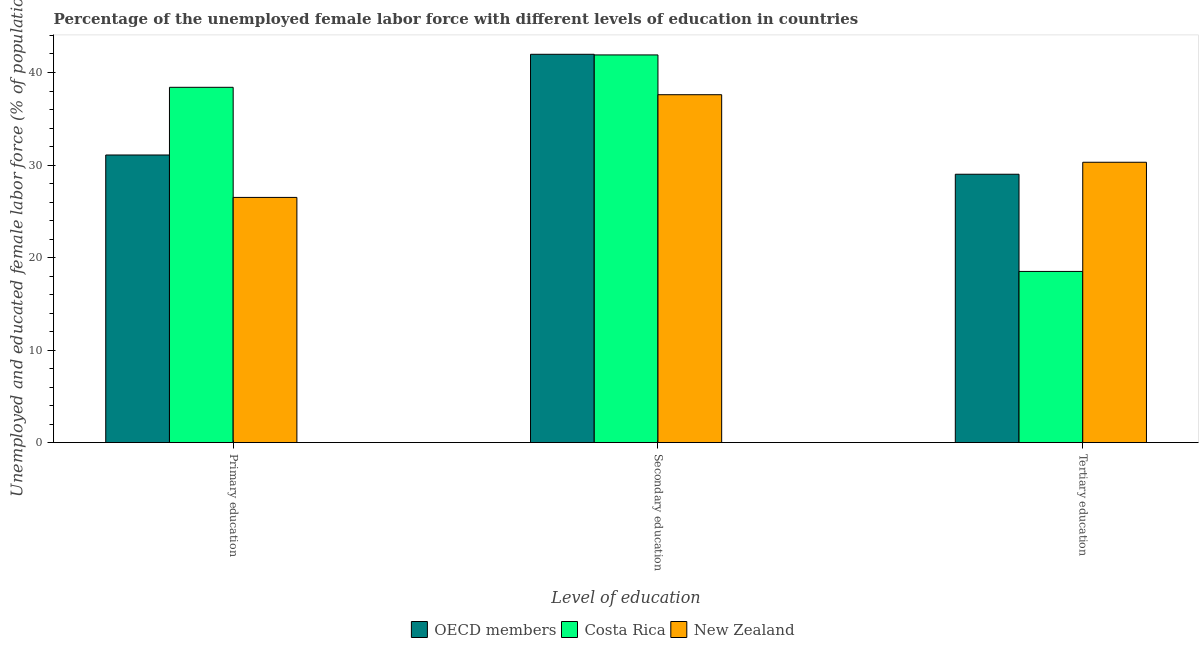How many groups of bars are there?
Offer a terse response. 3. Are the number of bars per tick equal to the number of legend labels?
Your answer should be compact. Yes. Are the number of bars on each tick of the X-axis equal?
Provide a succinct answer. Yes. How many bars are there on the 3rd tick from the left?
Your response must be concise. 3. How many bars are there on the 2nd tick from the right?
Your answer should be compact. 3. What is the label of the 2nd group of bars from the left?
Give a very brief answer. Secondary education. What is the percentage of female labor force who received primary education in OECD members?
Make the answer very short. 31.08. Across all countries, what is the maximum percentage of female labor force who received secondary education?
Offer a terse response. 41.97. In which country was the percentage of female labor force who received secondary education maximum?
Give a very brief answer. OECD members. In which country was the percentage of female labor force who received primary education minimum?
Provide a succinct answer. New Zealand. What is the total percentage of female labor force who received tertiary education in the graph?
Ensure brevity in your answer.  77.81. What is the difference between the percentage of female labor force who received primary education in Costa Rica and that in OECD members?
Your response must be concise. 7.32. What is the difference between the percentage of female labor force who received primary education in New Zealand and the percentage of female labor force who received secondary education in Costa Rica?
Offer a terse response. -15.4. What is the average percentage of female labor force who received secondary education per country?
Your response must be concise. 40.49. What is the difference between the percentage of female labor force who received tertiary education and percentage of female labor force who received secondary education in New Zealand?
Offer a very short reply. -7.3. What is the ratio of the percentage of female labor force who received tertiary education in New Zealand to that in Costa Rica?
Keep it short and to the point. 1.64. What is the difference between the highest and the second highest percentage of female labor force who received primary education?
Make the answer very short. 7.32. What is the difference between the highest and the lowest percentage of female labor force who received primary education?
Provide a short and direct response. 11.9. In how many countries, is the percentage of female labor force who received tertiary education greater than the average percentage of female labor force who received tertiary education taken over all countries?
Provide a short and direct response. 2. Is the sum of the percentage of female labor force who received tertiary education in Costa Rica and New Zealand greater than the maximum percentage of female labor force who received primary education across all countries?
Offer a very short reply. Yes. What does the 1st bar from the right in Secondary education represents?
Keep it short and to the point. New Zealand. Is it the case that in every country, the sum of the percentage of female labor force who received primary education and percentage of female labor force who received secondary education is greater than the percentage of female labor force who received tertiary education?
Ensure brevity in your answer.  Yes. How many bars are there?
Your answer should be compact. 9. Are all the bars in the graph horizontal?
Offer a terse response. No. Does the graph contain any zero values?
Offer a very short reply. No. Does the graph contain grids?
Your answer should be compact. No. How are the legend labels stacked?
Your answer should be very brief. Horizontal. What is the title of the graph?
Keep it short and to the point. Percentage of the unemployed female labor force with different levels of education in countries. What is the label or title of the X-axis?
Make the answer very short. Level of education. What is the label or title of the Y-axis?
Give a very brief answer. Unemployed and educated female labor force (% of population). What is the Unemployed and educated female labor force (% of population) in OECD members in Primary education?
Your answer should be very brief. 31.08. What is the Unemployed and educated female labor force (% of population) of Costa Rica in Primary education?
Provide a succinct answer. 38.4. What is the Unemployed and educated female labor force (% of population) in New Zealand in Primary education?
Your answer should be compact. 26.5. What is the Unemployed and educated female labor force (% of population) in OECD members in Secondary education?
Offer a very short reply. 41.97. What is the Unemployed and educated female labor force (% of population) of Costa Rica in Secondary education?
Your answer should be very brief. 41.9. What is the Unemployed and educated female labor force (% of population) in New Zealand in Secondary education?
Offer a terse response. 37.6. What is the Unemployed and educated female labor force (% of population) of OECD members in Tertiary education?
Your answer should be very brief. 29.01. What is the Unemployed and educated female labor force (% of population) in New Zealand in Tertiary education?
Your answer should be compact. 30.3. Across all Level of education, what is the maximum Unemployed and educated female labor force (% of population) in OECD members?
Make the answer very short. 41.97. Across all Level of education, what is the maximum Unemployed and educated female labor force (% of population) of Costa Rica?
Give a very brief answer. 41.9. Across all Level of education, what is the maximum Unemployed and educated female labor force (% of population) in New Zealand?
Offer a very short reply. 37.6. Across all Level of education, what is the minimum Unemployed and educated female labor force (% of population) of OECD members?
Ensure brevity in your answer.  29.01. Across all Level of education, what is the minimum Unemployed and educated female labor force (% of population) of New Zealand?
Offer a very short reply. 26.5. What is the total Unemployed and educated female labor force (% of population) of OECD members in the graph?
Your response must be concise. 102.06. What is the total Unemployed and educated female labor force (% of population) in Costa Rica in the graph?
Your answer should be compact. 98.8. What is the total Unemployed and educated female labor force (% of population) in New Zealand in the graph?
Your answer should be compact. 94.4. What is the difference between the Unemployed and educated female labor force (% of population) in OECD members in Primary education and that in Secondary education?
Make the answer very short. -10.88. What is the difference between the Unemployed and educated female labor force (% of population) of New Zealand in Primary education and that in Secondary education?
Make the answer very short. -11.1. What is the difference between the Unemployed and educated female labor force (% of population) in OECD members in Primary education and that in Tertiary education?
Keep it short and to the point. 2.08. What is the difference between the Unemployed and educated female labor force (% of population) of OECD members in Secondary education and that in Tertiary education?
Provide a short and direct response. 12.96. What is the difference between the Unemployed and educated female labor force (% of population) in Costa Rica in Secondary education and that in Tertiary education?
Provide a succinct answer. 23.4. What is the difference between the Unemployed and educated female labor force (% of population) of New Zealand in Secondary education and that in Tertiary education?
Your answer should be very brief. 7.3. What is the difference between the Unemployed and educated female labor force (% of population) of OECD members in Primary education and the Unemployed and educated female labor force (% of population) of Costa Rica in Secondary education?
Make the answer very short. -10.82. What is the difference between the Unemployed and educated female labor force (% of population) of OECD members in Primary education and the Unemployed and educated female labor force (% of population) of New Zealand in Secondary education?
Offer a terse response. -6.52. What is the difference between the Unemployed and educated female labor force (% of population) of OECD members in Primary education and the Unemployed and educated female labor force (% of population) of Costa Rica in Tertiary education?
Offer a terse response. 12.58. What is the difference between the Unemployed and educated female labor force (% of population) in OECD members in Primary education and the Unemployed and educated female labor force (% of population) in New Zealand in Tertiary education?
Make the answer very short. 0.78. What is the difference between the Unemployed and educated female labor force (% of population) in Costa Rica in Primary education and the Unemployed and educated female labor force (% of population) in New Zealand in Tertiary education?
Make the answer very short. 8.1. What is the difference between the Unemployed and educated female labor force (% of population) in OECD members in Secondary education and the Unemployed and educated female labor force (% of population) in Costa Rica in Tertiary education?
Make the answer very short. 23.47. What is the difference between the Unemployed and educated female labor force (% of population) of OECD members in Secondary education and the Unemployed and educated female labor force (% of population) of New Zealand in Tertiary education?
Offer a very short reply. 11.67. What is the difference between the Unemployed and educated female labor force (% of population) of Costa Rica in Secondary education and the Unemployed and educated female labor force (% of population) of New Zealand in Tertiary education?
Provide a short and direct response. 11.6. What is the average Unemployed and educated female labor force (% of population) of OECD members per Level of education?
Your response must be concise. 34.02. What is the average Unemployed and educated female labor force (% of population) of Costa Rica per Level of education?
Your answer should be compact. 32.93. What is the average Unemployed and educated female labor force (% of population) of New Zealand per Level of education?
Provide a succinct answer. 31.47. What is the difference between the Unemployed and educated female labor force (% of population) in OECD members and Unemployed and educated female labor force (% of population) in Costa Rica in Primary education?
Keep it short and to the point. -7.32. What is the difference between the Unemployed and educated female labor force (% of population) in OECD members and Unemployed and educated female labor force (% of population) in New Zealand in Primary education?
Your answer should be very brief. 4.58. What is the difference between the Unemployed and educated female labor force (% of population) of OECD members and Unemployed and educated female labor force (% of population) of Costa Rica in Secondary education?
Your response must be concise. 0.07. What is the difference between the Unemployed and educated female labor force (% of population) in OECD members and Unemployed and educated female labor force (% of population) in New Zealand in Secondary education?
Give a very brief answer. 4.37. What is the difference between the Unemployed and educated female labor force (% of population) of Costa Rica and Unemployed and educated female labor force (% of population) of New Zealand in Secondary education?
Your response must be concise. 4.3. What is the difference between the Unemployed and educated female labor force (% of population) in OECD members and Unemployed and educated female labor force (% of population) in Costa Rica in Tertiary education?
Your answer should be very brief. 10.51. What is the difference between the Unemployed and educated female labor force (% of population) in OECD members and Unemployed and educated female labor force (% of population) in New Zealand in Tertiary education?
Offer a terse response. -1.29. What is the ratio of the Unemployed and educated female labor force (% of population) in OECD members in Primary education to that in Secondary education?
Provide a short and direct response. 0.74. What is the ratio of the Unemployed and educated female labor force (% of population) in Costa Rica in Primary education to that in Secondary education?
Provide a short and direct response. 0.92. What is the ratio of the Unemployed and educated female labor force (% of population) of New Zealand in Primary education to that in Secondary education?
Ensure brevity in your answer.  0.7. What is the ratio of the Unemployed and educated female labor force (% of population) of OECD members in Primary education to that in Tertiary education?
Give a very brief answer. 1.07. What is the ratio of the Unemployed and educated female labor force (% of population) in Costa Rica in Primary education to that in Tertiary education?
Provide a short and direct response. 2.08. What is the ratio of the Unemployed and educated female labor force (% of population) in New Zealand in Primary education to that in Tertiary education?
Your answer should be compact. 0.87. What is the ratio of the Unemployed and educated female labor force (% of population) in OECD members in Secondary education to that in Tertiary education?
Your response must be concise. 1.45. What is the ratio of the Unemployed and educated female labor force (% of population) of Costa Rica in Secondary education to that in Tertiary education?
Offer a very short reply. 2.26. What is the ratio of the Unemployed and educated female labor force (% of population) of New Zealand in Secondary education to that in Tertiary education?
Ensure brevity in your answer.  1.24. What is the difference between the highest and the second highest Unemployed and educated female labor force (% of population) in OECD members?
Make the answer very short. 10.88. What is the difference between the highest and the second highest Unemployed and educated female labor force (% of population) in Costa Rica?
Provide a succinct answer. 3.5. What is the difference between the highest and the lowest Unemployed and educated female labor force (% of population) of OECD members?
Give a very brief answer. 12.96. What is the difference between the highest and the lowest Unemployed and educated female labor force (% of population) of Costa Rica?
Make the answer very short. 23.4. What is the difference between the highest and the lowest Unemployed and educated female labor force (% of population) in New Zealand?
Keep it short and to the point. 11.1. 